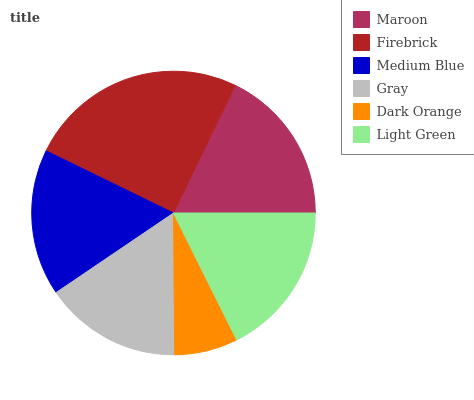Is Dark Orange the minimum?
Answer yes or no. Yes. Is Firebrick the maximum?
Answer yes or no. Yes. Is Medium Blue the minimum?
Answer yes or no. No. Is Medium Blue the maximum?
Answer yes or no. No. Is Firebrick greater than Medium Blue?
Answer yes or no. Yes. Is Medium Blue less than Firebrick?
Answer yes or no. Yes. Is Medium Blue greater than Firebrick?
Answer yes or no. No. Is Firebrick less than Medium Blue?
Answer yes or no. No. Is Light Green the high median?
Answer yes or no. Yes. Is Medium Blue the low median?
Answer yes or no. Yes. Is Dark Orange the high median?
Answer yes or no. No. Is Dark Orange the low median?
Answer yes or no. No. 